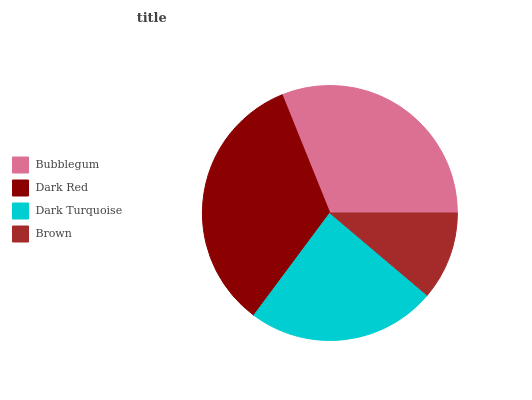Is Brown the minimum?
Answer yes or no. Yes. Is Dark Red the maximum?
Answer yes or no. Yes. Is Dark Turquoise the minimum?
Answer yes or no. No. Is Dark Turquoise the maximum?
Answer yes or no. No. Is Dark Red greater than Dark Turquoise?
Answer yes or no. Yes. Is Dark Turquoise less than Dark Red?
Answer yes or no. Yes. Is Dark Turquoise greater than Dark Red?
Answer yes or no. No. Is Dark Red less than Dark Turquoise?
Answer yes or no. No. Is Bubblegum the high median?
Answer yes or no. Yes. Is Dark Turquoise the low median?
Answer yes or no. Yes. Is Brown the high median?
Answer yes or no. No. Is Bubblegum the low median?
Answer yes or no. No. 